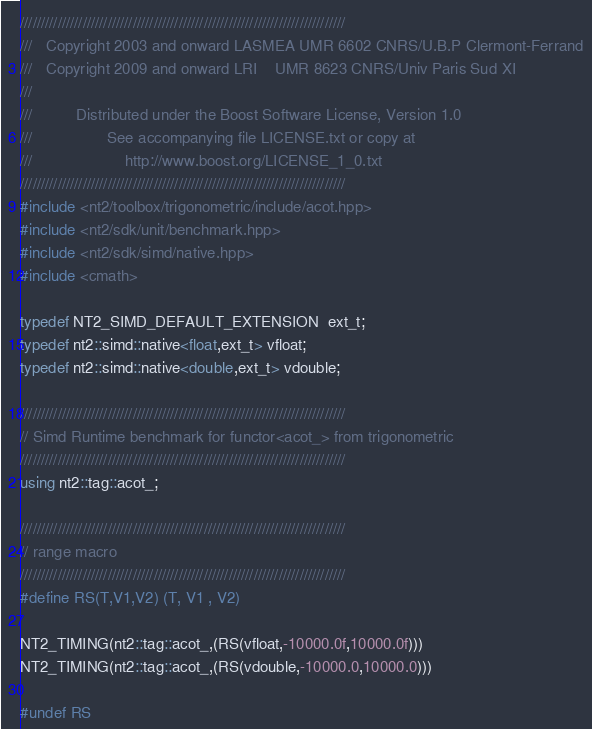Convert code to text. <code><loc_0><loc_0><loc_500><loc_500><_C++_>//////////////////////////////////////////////////////////////////////////////
///   Copyright 2003 and onward LASMEA UMR 6602 CNRS/U.B.P Clermont-Ferrand
///   Copyright 2009 and onward LRI    UMR 8623 CNRS/Univ Paris Sud XI
///
///          Distributed under the Boost Software License, Version 1.0
///                 See accompanying file LICENSE.txt or copy at
///                     http://www.boost.org/LICENSE_1_0.txt
//////////////////////////////////////////////////////////////////////////////
#include <nt2/toolbox/trigonometric/include/acot.hpp>
#include <nt2/sdk/unit/benchmark.hpp>
#include <nt2/sdk/simd/native.hpp>
#include <cmath>

typedef NT2_SIMD_DEFAULT_EXTENSION  ext_t;
typedef nt2::simd::native<float,ext_t> vfloat;
typedef nt2::simd::native<double,ext_t> vdouble;

//////////////////////////////////////////////////////////////////////////////
// Simd Runtime benchmark for functor<acot_> from trigonometric
//////////////////////////////////////////////////////////////////////////////
using nt2::tag::acot_;

//////////////////////////////////////////////////////////////////////////////
// range macro
//////////////////////////////////////////////////////////////////////////////
#define RS(T,V1,V2) (T, V1 , V2)

NT2_TIMING(nt2::tag::acot_,(RS(vfloat,-10000.0f,10000.0f)))
NT2_TIMING(nt2::tag::acot_,(RS(vdouble,-10000.0,10000.0)))

#undef RS</code> 